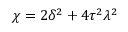Convert formula to latex. <formula><loc_0><loc_0><loc_500><loc_500>\chi = 2 \delta ^ { 2 } + 4 \tau ^ { 2 } \lambda ^ { 2 }</formula> 